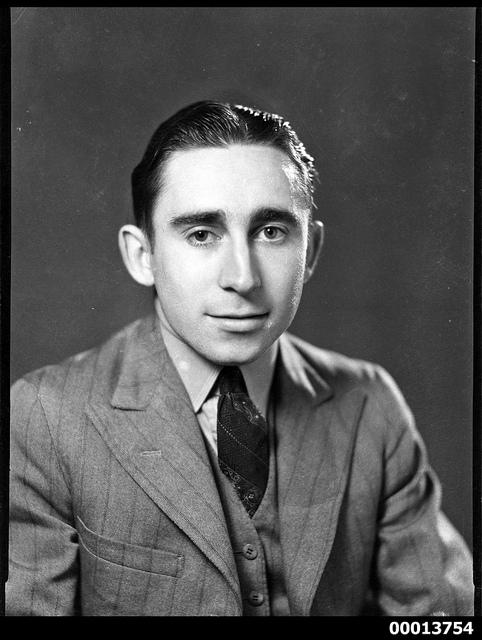What color is the tie?
Write a very short answer. Black. Is this a modern photo?
Keep it brief. No. What style suit is this known as?
Give a very brief answer. Pinstripe. 